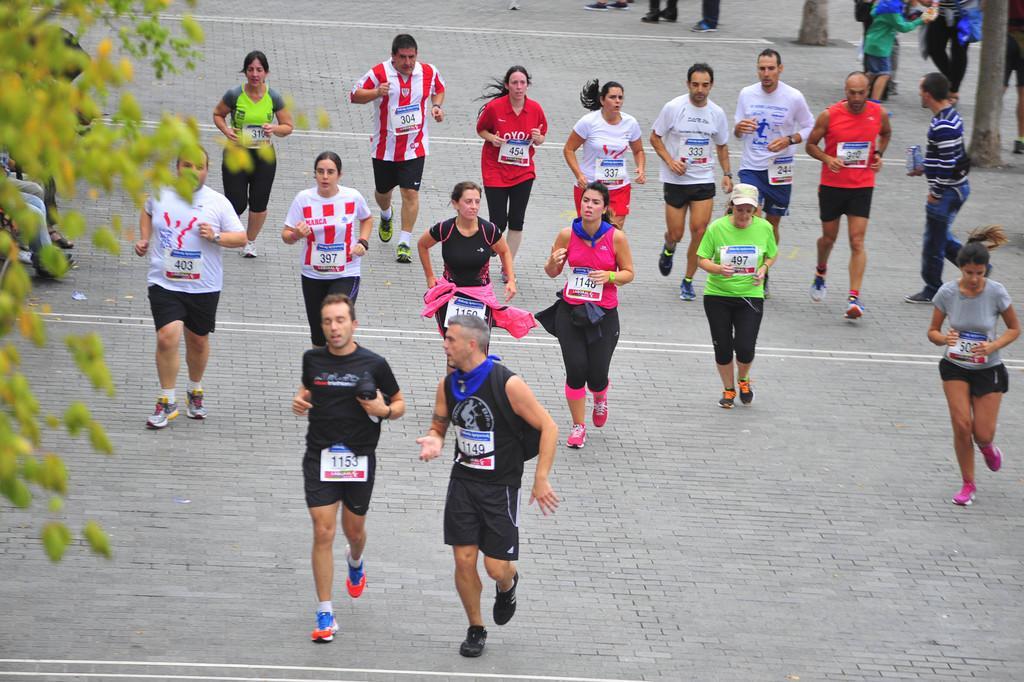Could you give a brief overview of what you see in this image? This picture describes about group of people, few people are running and few are standing, and we can find few trees. 